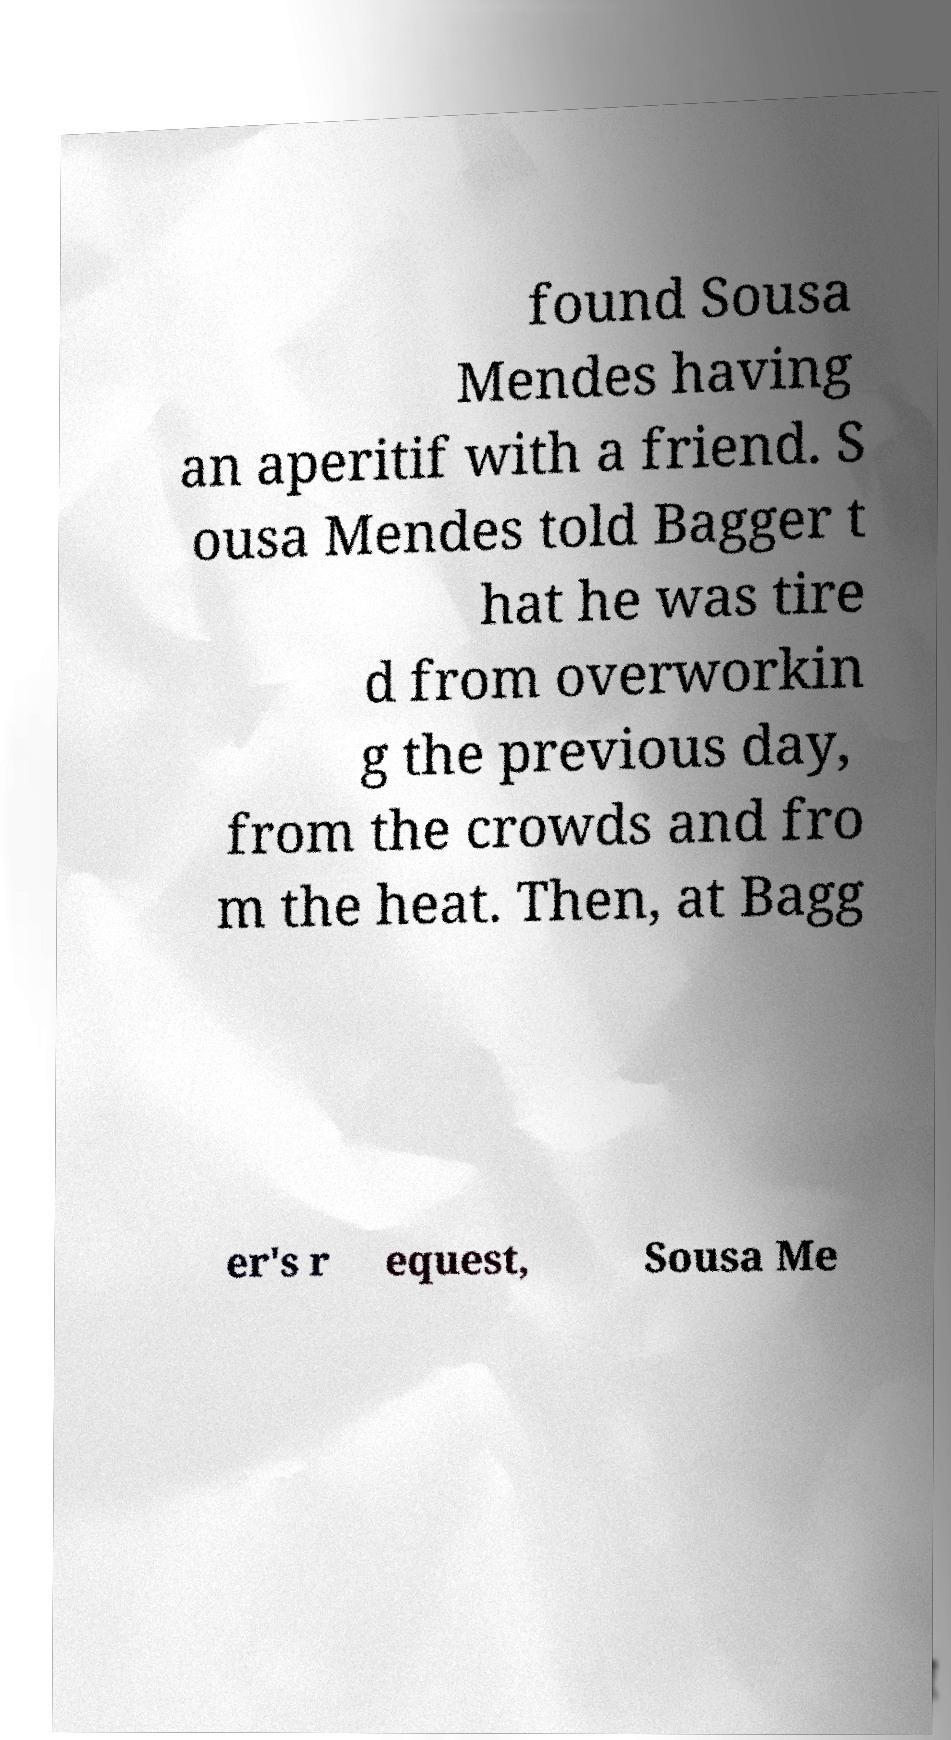Can you accurately transcribe the text from the provided image for me? found Sousa Mendes having an aperitif with a friend. S ousa Mendes told Bagger t hat he was tire d from overworkin g the previous day, from the crowds and fro m the heat. Then, at Bagg er's r equest, Sousa Me 